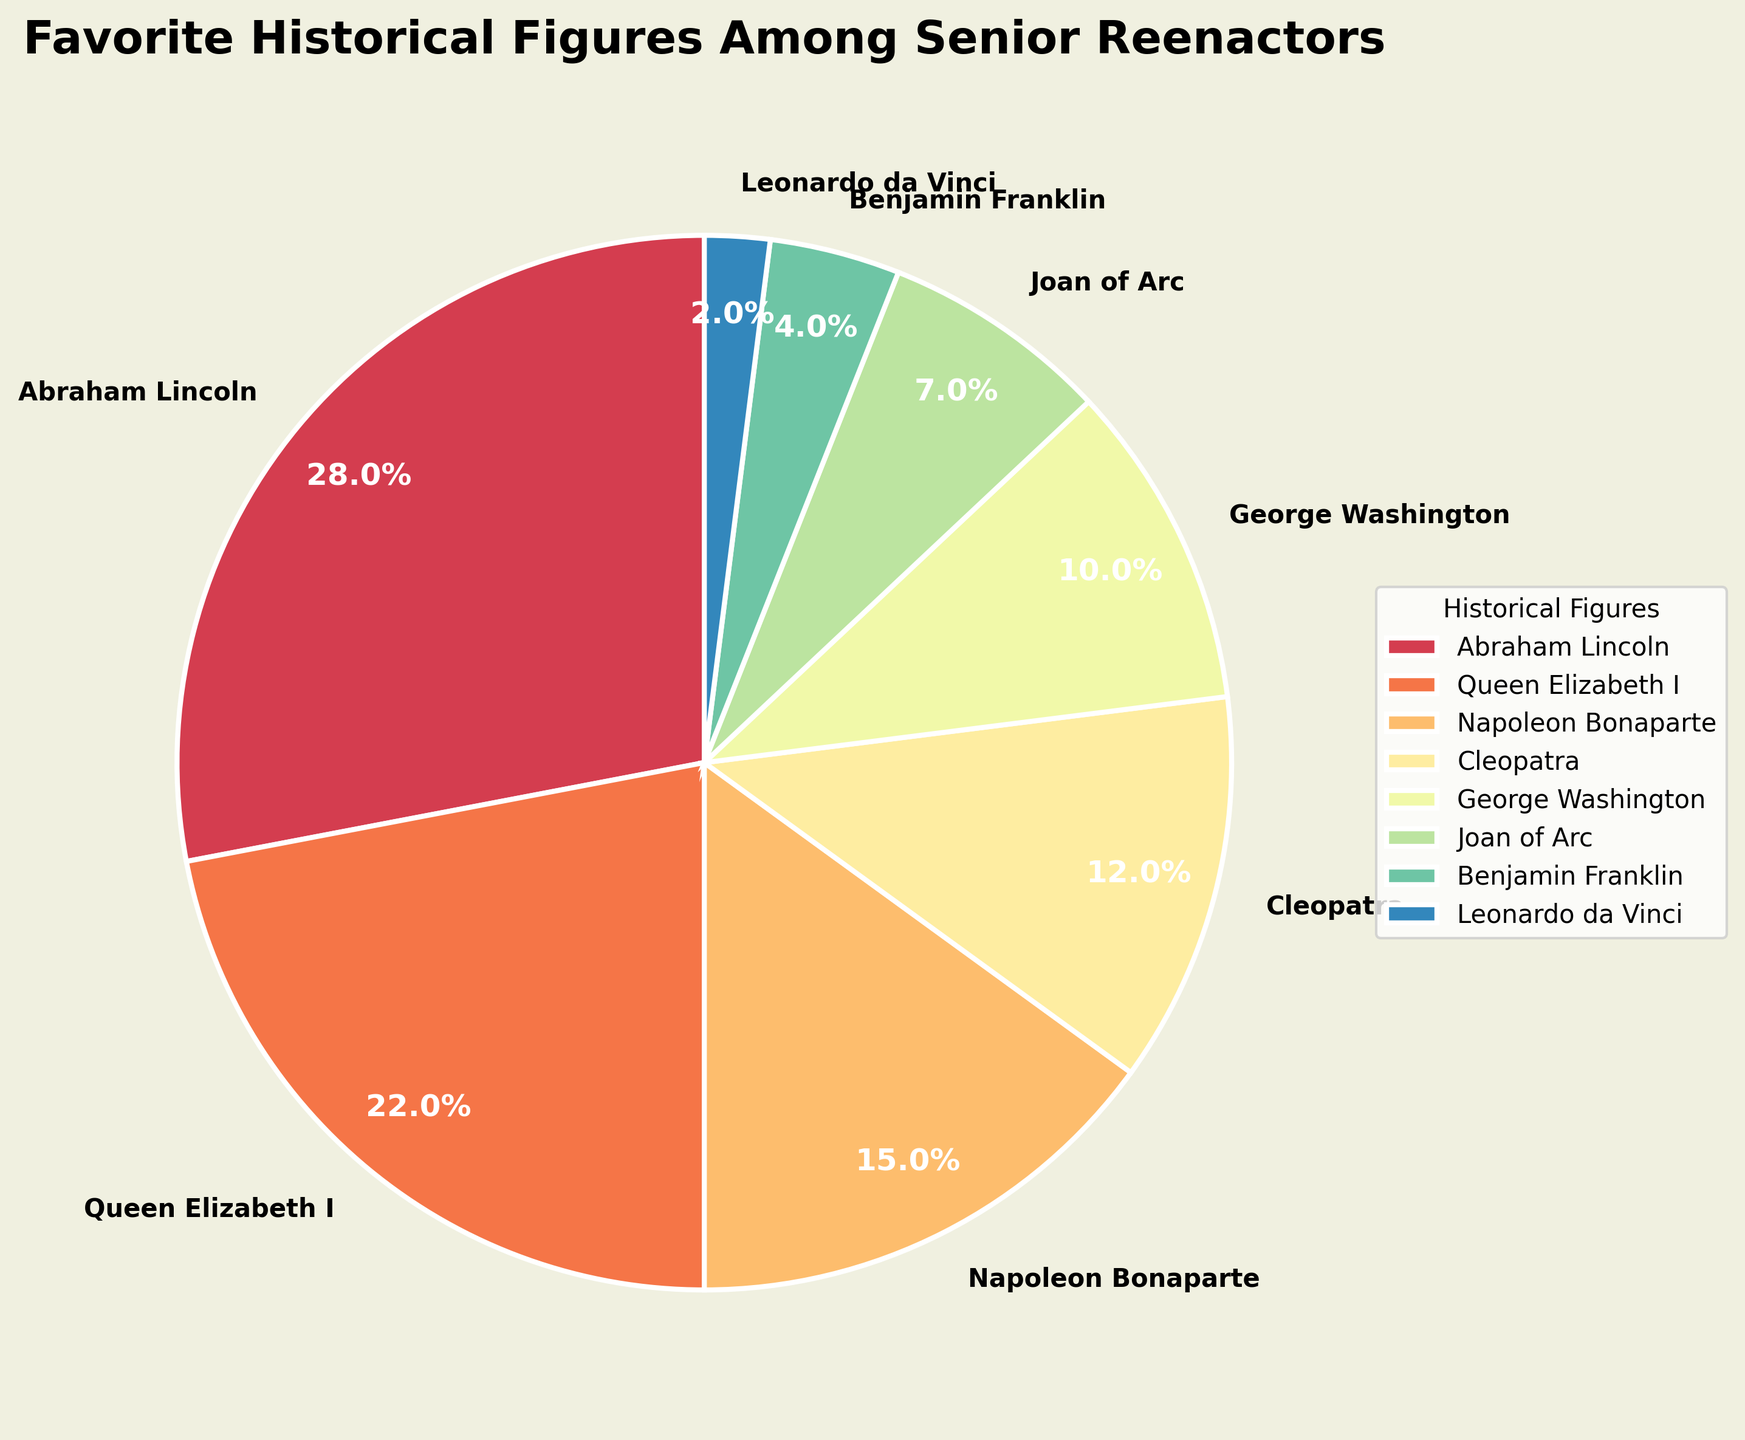Which historical figure is the most popular among senior reenactors? The figure shows the percentage of preferences for each historical figure. Abraham Lincoln has the highest percentage of 28%.
Answer: Abraham Lincoln What is the combined percentage of preferences for Queen Elizabeth I and George Washington? Add the percentages for Queen Elizabeth I and George Washington: 22% + 10% = 32%.
Answer: 32% How much more popular is Abraham Lincoln compared to Joan of Arc? Subtract the percentage for Joan of Arc (7%) from Abraham Lincoln's (28%): 28% - 7% = 21%.
Answer: 21% Which two historical figures have the lowest popularity? From the chart, Leonardo da Vinci has 2% and Benjamin Franklin has 4%, which are the two lowest percentages.
Answer: Leonardo da Vinci and Benjamin Franklin Are Cleopatra and Napoleon Bonaparte equally popular? Compare the percentages: Cleopatra has 12% and Napoleon Bonaparte has 15%, so they are not equally popular.
Answer: No How does the popularity of George Washington compare to that of Cleopatra? George Washington has 10% while Cleopatra has 12%, so Cleopatra is slightly more popular.
Answer: Cleopatra What is the average percentage for the top three historical figures? Add the percentages for Abraham Lincoln, Queen Elizabeth I, and Napoleon Bonaparte, then divide by 3: (28% + 22% + 15%) / 3 = 65% / 3 ≈ 21.67%.
Answer: 21.67% What is the difference in popularity between the most and least popular figures? Subtract the percentage of the least popular (Leonardo da Vinci, 2%) from the most popular (Abraham Lincoln, 28%): 28% - 2% = 26%.
Answer: 26% What color wedge represents Joan of Arc? The pie chart uses a spectral color scheme. Joan of Arc is represented by the wedge that is likely golden yellow, given her position on the spectrum.
Answer: Golden yellow Is Napoleon Bonaparte less popular than Queen Elizabeth I? Compare the percentages: Napoleon Bonaparte has 15%, and Queen Elizabeth I has 22%, indicating Napoleon is less popular.
Answer: Yes 